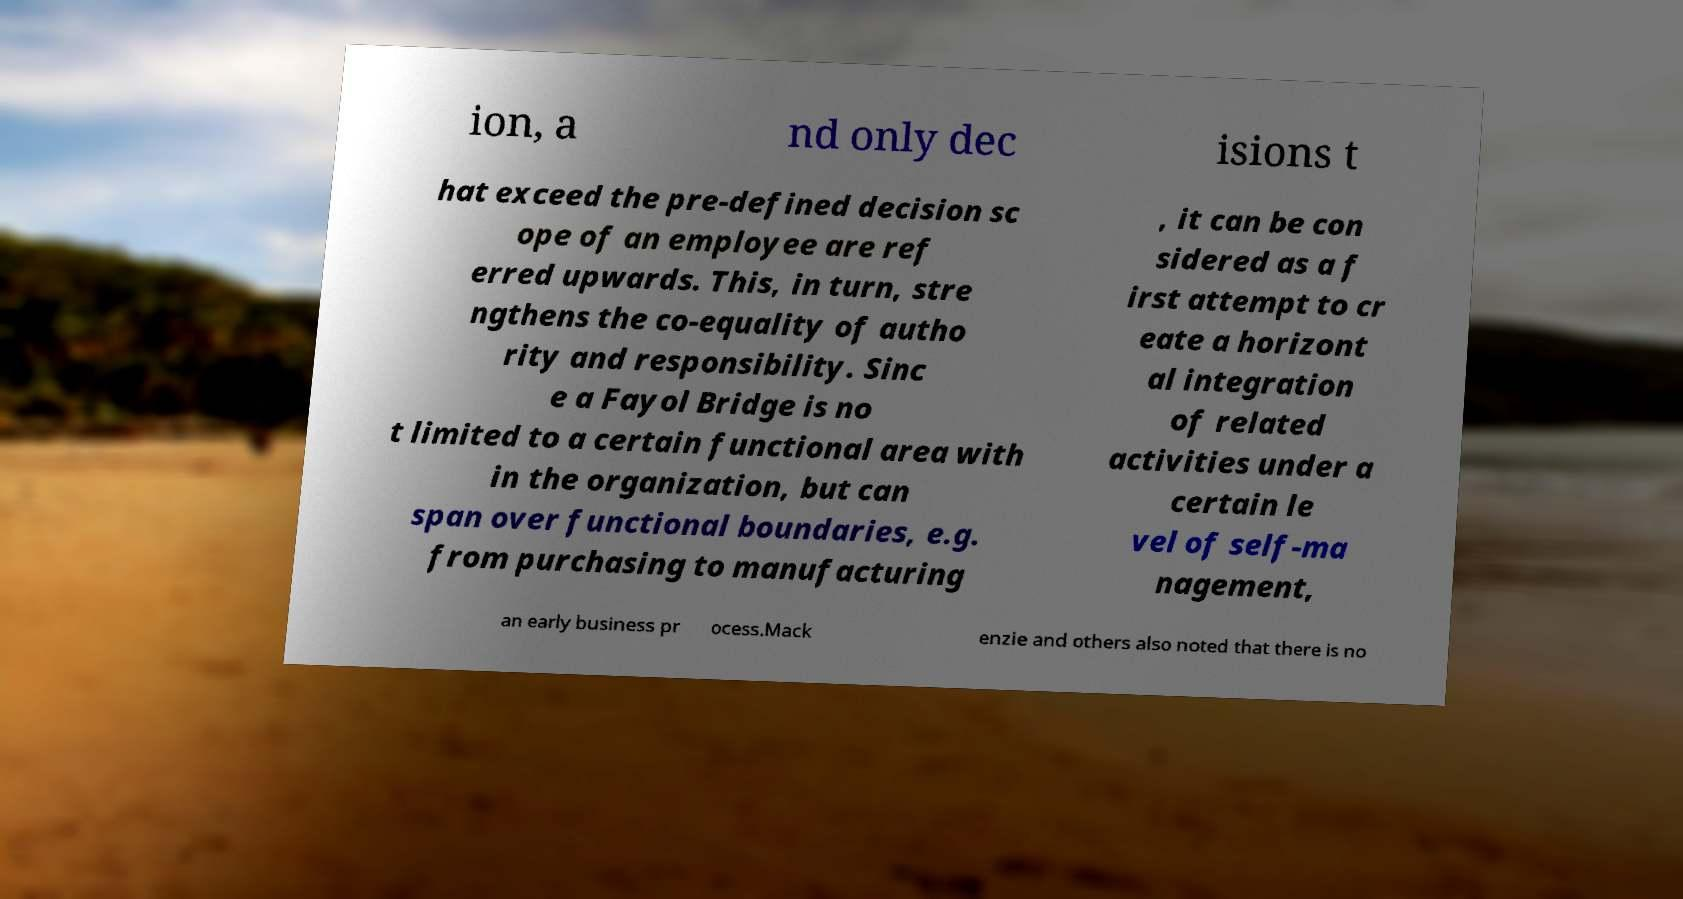There's text embedded in this image that I need extracted. Can you transcribe it verbatim? ion, a nd only dec isions t hat exceed the pre-defined decision sc ope of an employee are ref erred upwards. This, in turn, stre ngthens the co-equality of autho rity and responsibility. Sinc e a Fayol Bridge is no t limited to a certain functional area with in the organization, but can span over functional boundaries, e.g. from purchasing to manufacturing , it can be con sidered as a f irst attempt to cr eate a horizont al integration of related activities under a certain le vel of self-ma nagement, an early business pr ocess.Mack enzie and others also noted that there is no 